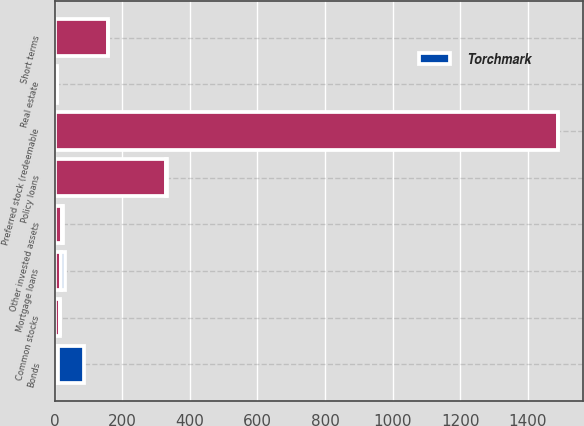Convert chart to OTSL. <chart><loc_0><loc_0><loc_500><loc_500><stacked_bar_chart><ecel><fcel>Bonds<fcel>Preferred stock (redeemable<fcel>Common stocks<fcel>Mortgage loans<fcel>Real estate<fcel>Policy loans<fcel>Other invested assets<fcel>Short terms<nl><fcel>nan<fcel>10.1<fcel>1488<fcel>15<fcel>20<fcel>8<fcel>329<fcel>21<fcel>157<nl><fcel>Torchmark<fcel>78<fcel>0.8<fcel>2.6<fcel>10.1<fcel>0.5<fcel>3.8<fcel>3<fcel>1.2<nl></chart> 